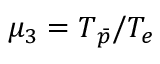<formula> <loc_0><loc_0><loc_500><loc_500>\mu _ { 3 } = T _ { \bar { p } } / T _ { e }</formula> 